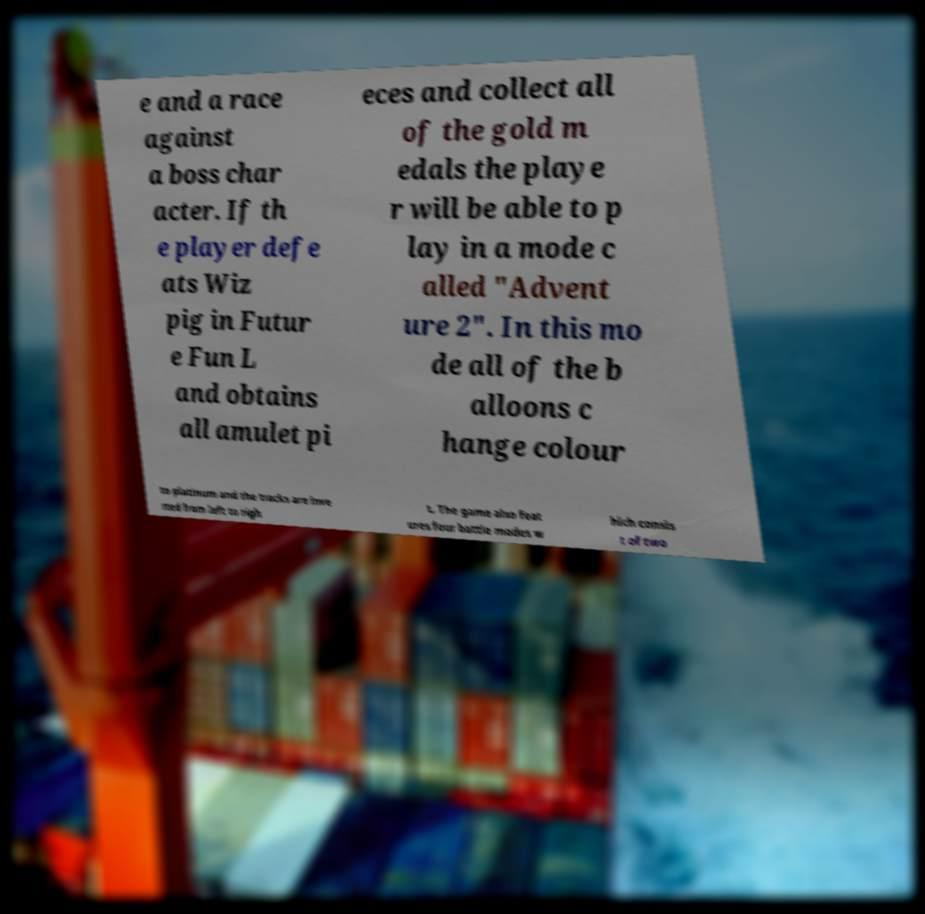Could you extract and type out the text from this image? e and a race against a boss char acter. If th e player defe ats Wiz pig in Futur e Fun L and obtains all amulet pi eces and collect all of the gold m edals the playe r will be able to p lay in a mode c alled "Advent ure 2". In this mo de all of the b alloons c hange colour to platinum and the tracks are inve rted from left to righ t. The game also feat ures four battle modes w hich consis t of two 